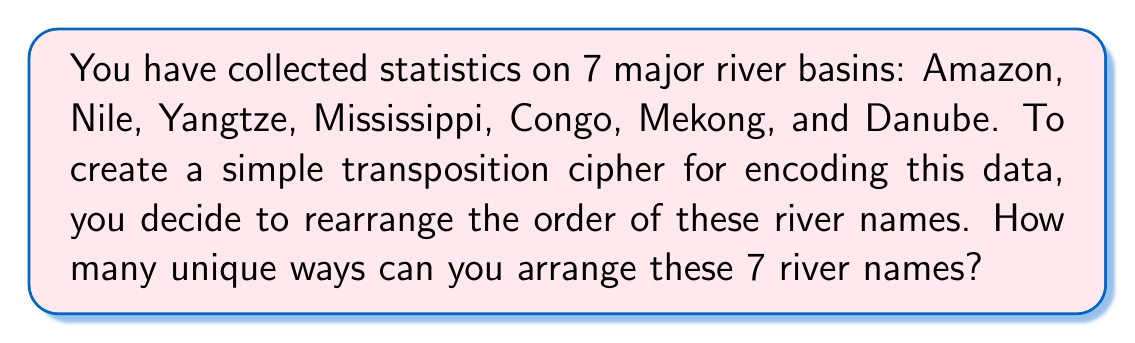What is the answer to this math problem? To solve this problem, we need to understand the concept of permutations. A permutation is an arrangement of objects where order matters.

1) We have 7 distinct river names to arrange.

2) For the first position, we have 7 choices.

3) After placing one river name, we have 6 choices for the second position.

4) This continues until we have only 1 choice for the last position.

5) The total number of permutations is the product of these choices:

   $$7 \times 6 \times 5 \times 4 \times 3 \times 2 \times 1$$

6) This is known as 7 factorial, denoted as $7!$

7) Calculate:
   $$7! = 7 \times 6 \times 5 \times 4 \times 3 \times 2 \times 1 = 5040$$

Therefore, there are 5040 unique ways to arrange these 7 river names for the transposition cipher.
Answer: $5040$ 